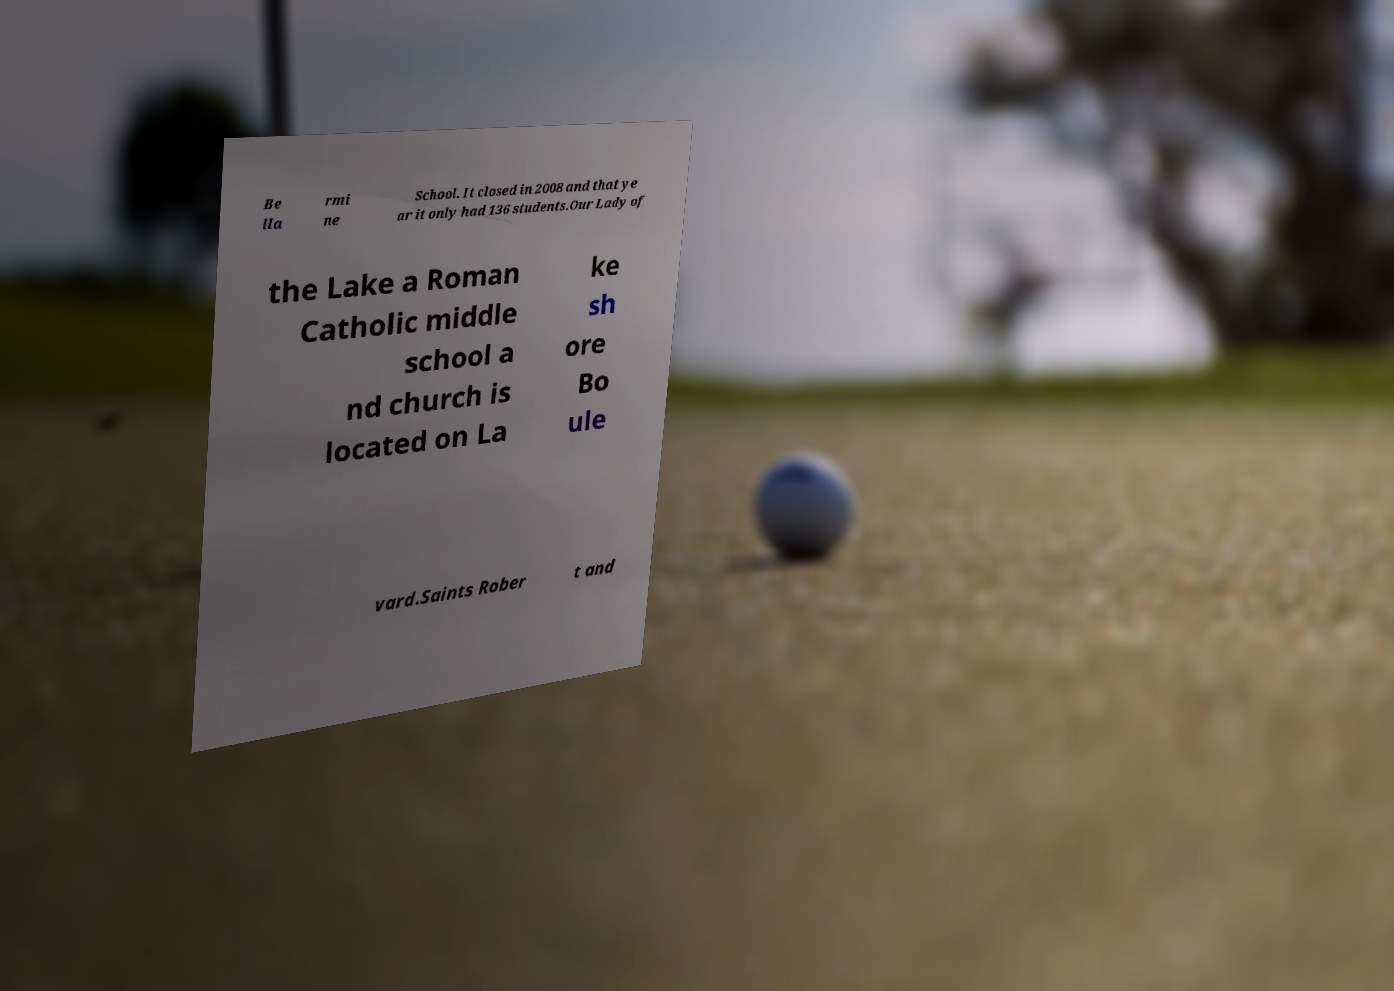What messages or text are displayed in this image? I need them in a readable, typed format. Be lla rmi ne School. It closed in 2008 and that ye ar it only had 136 students.Our Lady of the Lake a Roman Catholic middle school a nd church is located on La ke sh ore Bo ule vard.Saints Rober t and 